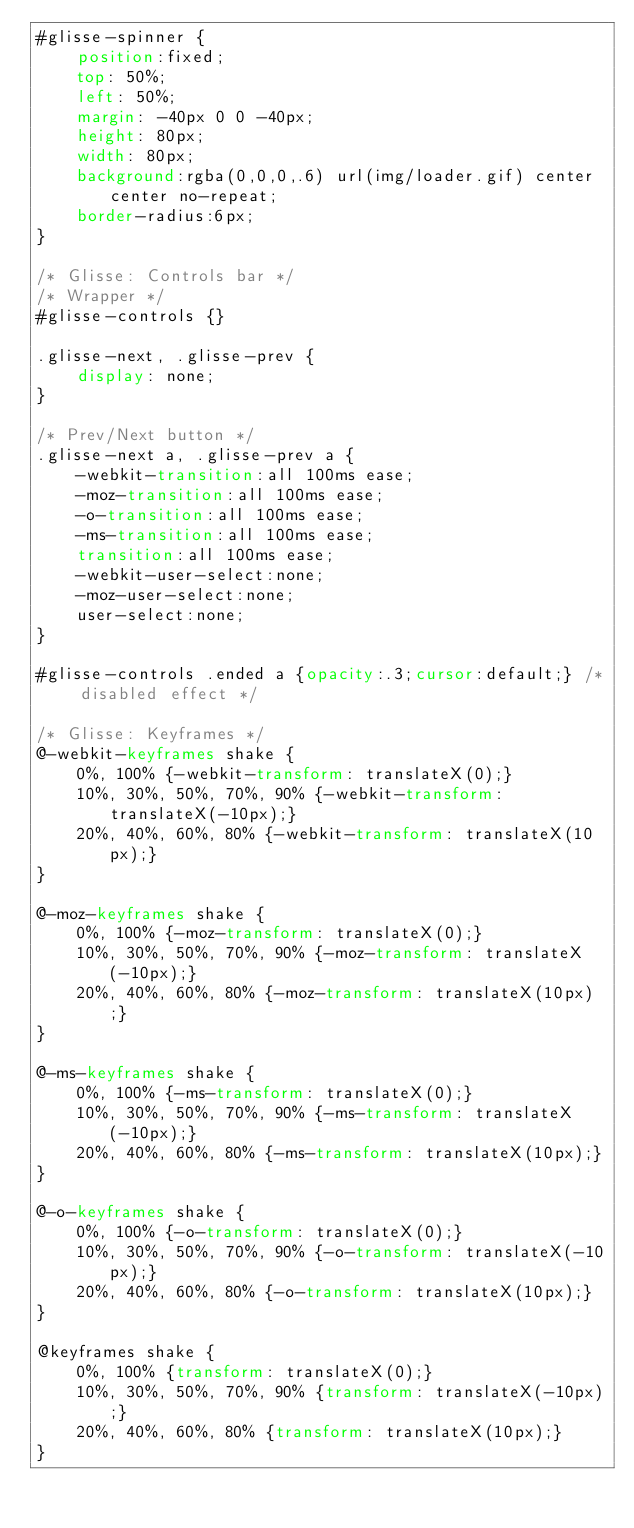Convert code to text. <code><loc_0><loc_0><loc_500><loc_500><_CSS_>#glisse-spinner {
    position:fixed;
    top: 50%;
    left: 50%;
    margin: -40px 0 0 -40px;
    height: 80px;
    width: 80px;
    background:rgba(0,0,0,.6) url(img/loader.gif) center center no-repeat;
    border-radius:6px;
}

/* Glisse: Controls bar */
/* Wrapper */
#glisse-controls {}
    
.glisse-next, .glisse-prev {
	display: none;
}

/* Prev/Next button */
.glisse-next a, .glisse-prev a {
	-webkit-transition:all 100ms ease;
	-moz-transition:all 100ms ease;
	-o-transition:all 100ms ease;
	-ms-transition:all 100ms ease;
	transition:all 100ms ease;
	-webkit-user-select:none;
	-moz-user-select:none;
	user-select:none;
}

#glisse-controls .ended a {opacity:.3;cursor:default;} /* disabled effect */

/* Glisse: Keyframes */
@-webkit-keyframes shake {
    0%, 100% {-webkit-transform: translateX(0);}
    10%, 30%, 50%, 70%, 90% {-webkit-transform: translateX(-10px);}
    20%, 40%, 60%, 80% {-webkit-transform: translateX(10px);}
}

@-moz-keyframes shake {
    0%, 100% {-moz-transform: translateX(0);}
    10%, 30%, 50%, 70%, 90% {-moz-transform: translateX(-10px);}
    20%, 40%, 60%, 80% {-moz-transform: translateX(10px);}
}

@-ms-keyframes shake {
    0%, 100% {-ms-transform: translateX(0);}
    10%, 30%, 50%, 70%, 90% {-ms-transform: translateX(-10px);}
    20%, 40%, 60%, 80% {-ms-transform: translateX(10px);}
}

@-o-keyframes shake {
    0%, 100% {-o-transform: translateX(0);}
    10%, 30%, 50%, 70%, 90% {-o-transform: translateX(-10px);}
    20%, 40%, 60%, 80% {-o-transform: translateX(10px);}
}

@keyframes shake {
    0%, 100% {transform: translateX(0);}
    10%, 30%, 50%, 70%, 90% {transform: translateX(-10px);}
    20%, 40%, 60%, 80% {transform: translateX(10px);}
}</code> 